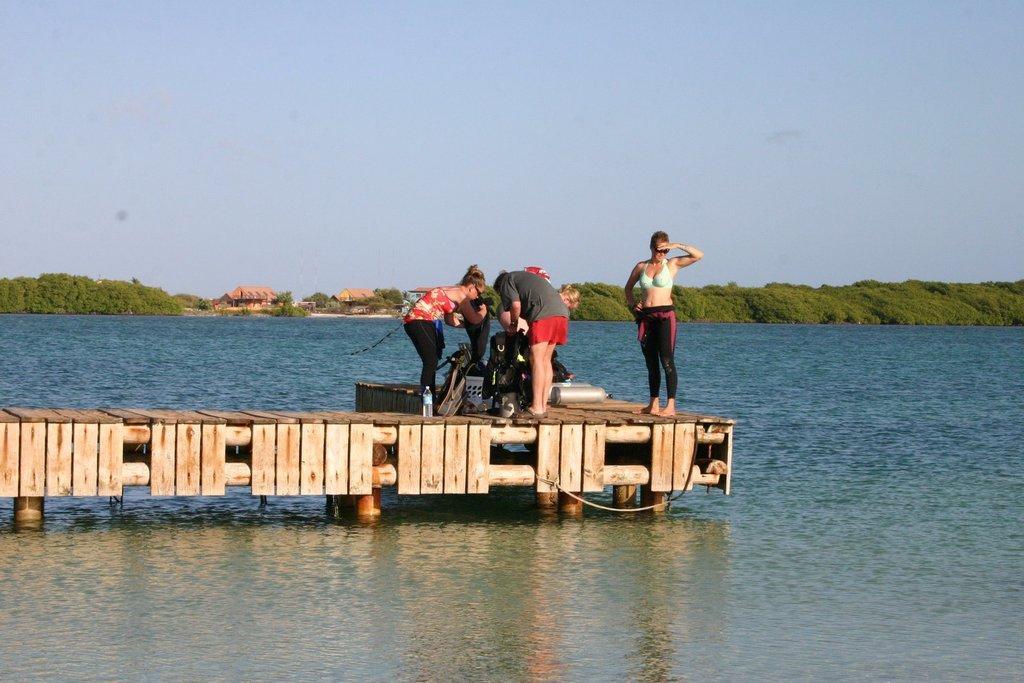Describe this image in one or two sentences. In the center of the image we can see some persons are standing on a bridge and we can see a bottle, bag, cylinder and some objects. In the background of the image we can see the water. In the middle of the image we can see the buildings, trees. At the top of the image we can see the sky. 